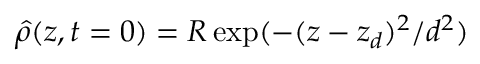Convert formula to latex. <formula><loc_0><loc_0><loc_500><loc_500>\hat { \rho } ( z , t = 0 ) = R \exp ( - ( z - z _ { d } ) ^ { 2 } / d ^ { 2 } )</formula> 